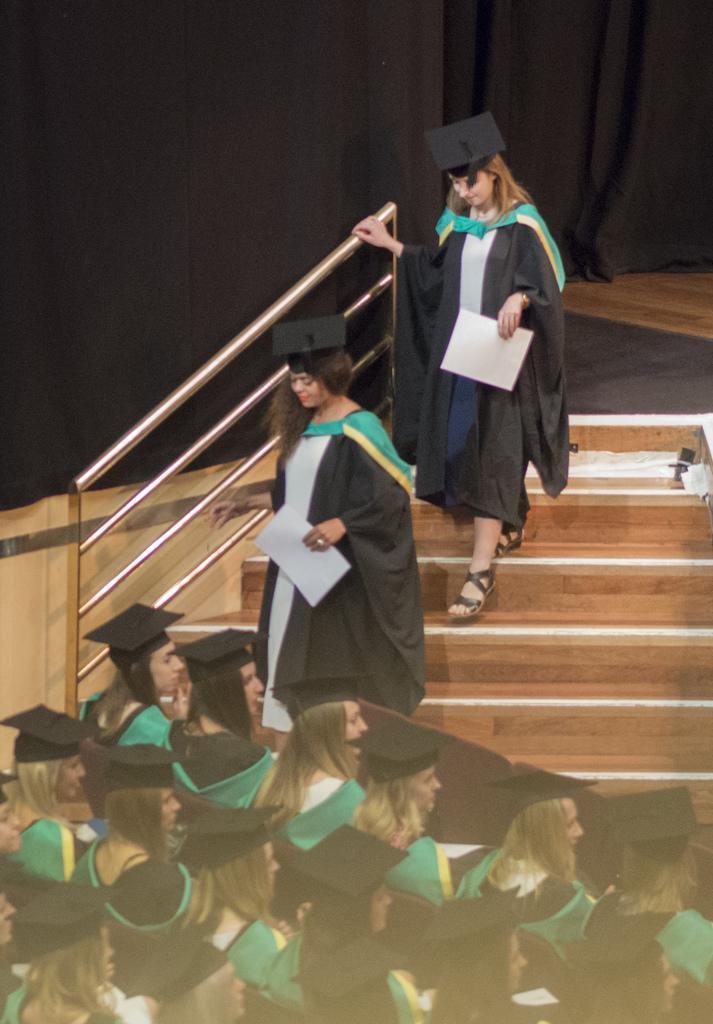In one or two sentences, can you explain what this image depicts? In this picture I can observe some women. They are wearing academic dresses. On the left side I can observe a railing. In the background I can observe black color curtains. 